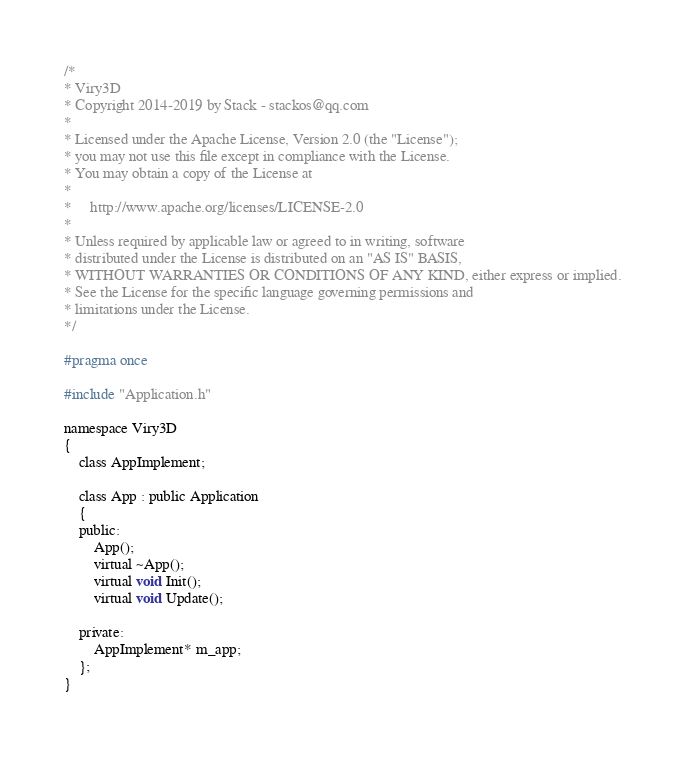Convert code to text. <code><loc_0><loc_0><loc_500><loc_500><_C_>/*
* Viry3D
* Copyright 2014-2019 by Stack - stackos@qq.com
*
* Licensed under the Apache License, Version 2.0 (the "License");
* you may not use this file except in compliance with the License.
* You may obtain a copy of the License at
*
*     http://www.apache.org/licenses/LICENSE-2.0
*
* Unless required by applicable law or agreed to in writing, software
* distributed under the License is distributed on an "AS IS" BASIS,
* WITHOUT WARRANTIES OR CONDITIONS OF ANY KIND, either express or implied.
* See the License for the specific language governing permissions and
* limitations under the License.
*/

#pragma once

#include "Application.h"

namespace Viry3D
{
    class AppImplement;

    class App : public Application
    {
    public:
        App();
        virtual ~App();
        virtual void Init();
        virtual void Update();

    private:
        AppImplement* m_app;
    };
}
</code> 